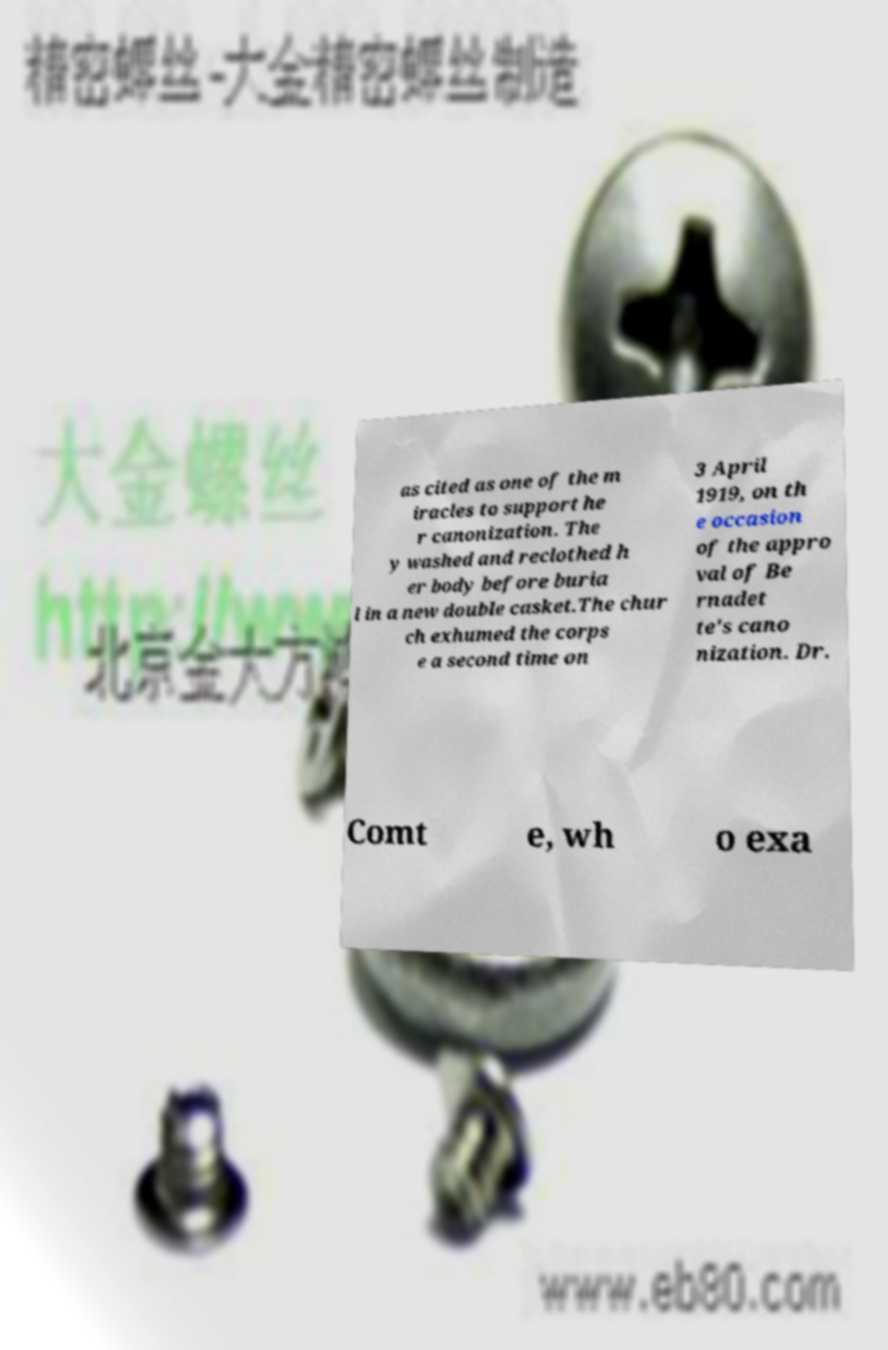Please identify and transcribe the text found in this image. as cited as one of the m iracles to support he r canonization. The y washed and reclothed h er body before buria l in a new double casket.The chur ch exhumed the corps e a second time on 3 April 1919, on th e occasion of the appro val of Be rnadet te's cano nization. Dr. Comt e, wh o exa 